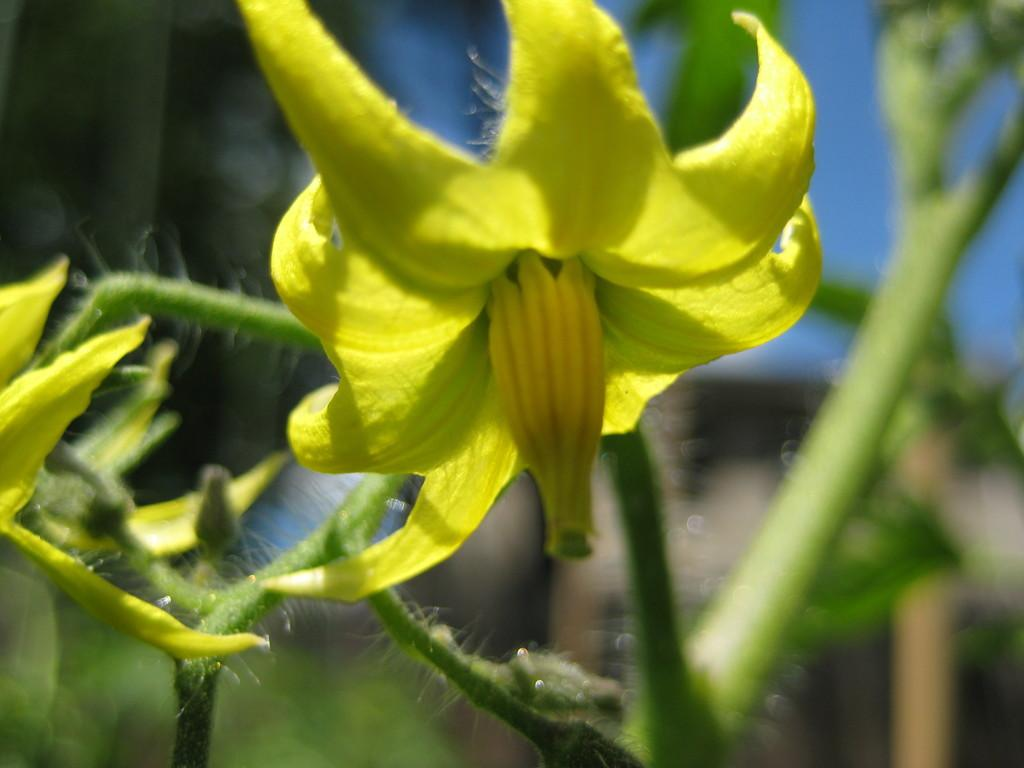What type of plants can be seen in the image? There are flowers in the image. What else can be seen in the background of the image? There are leaves and the sky visible in the background of the image. How would you describe the overall quality of the image? The image is blurry. What type of religion is being practiced by the ladybug in the image? There is no ladybug present in the image, so it is not possible to determine what religion might be practiced by a ladybug. 